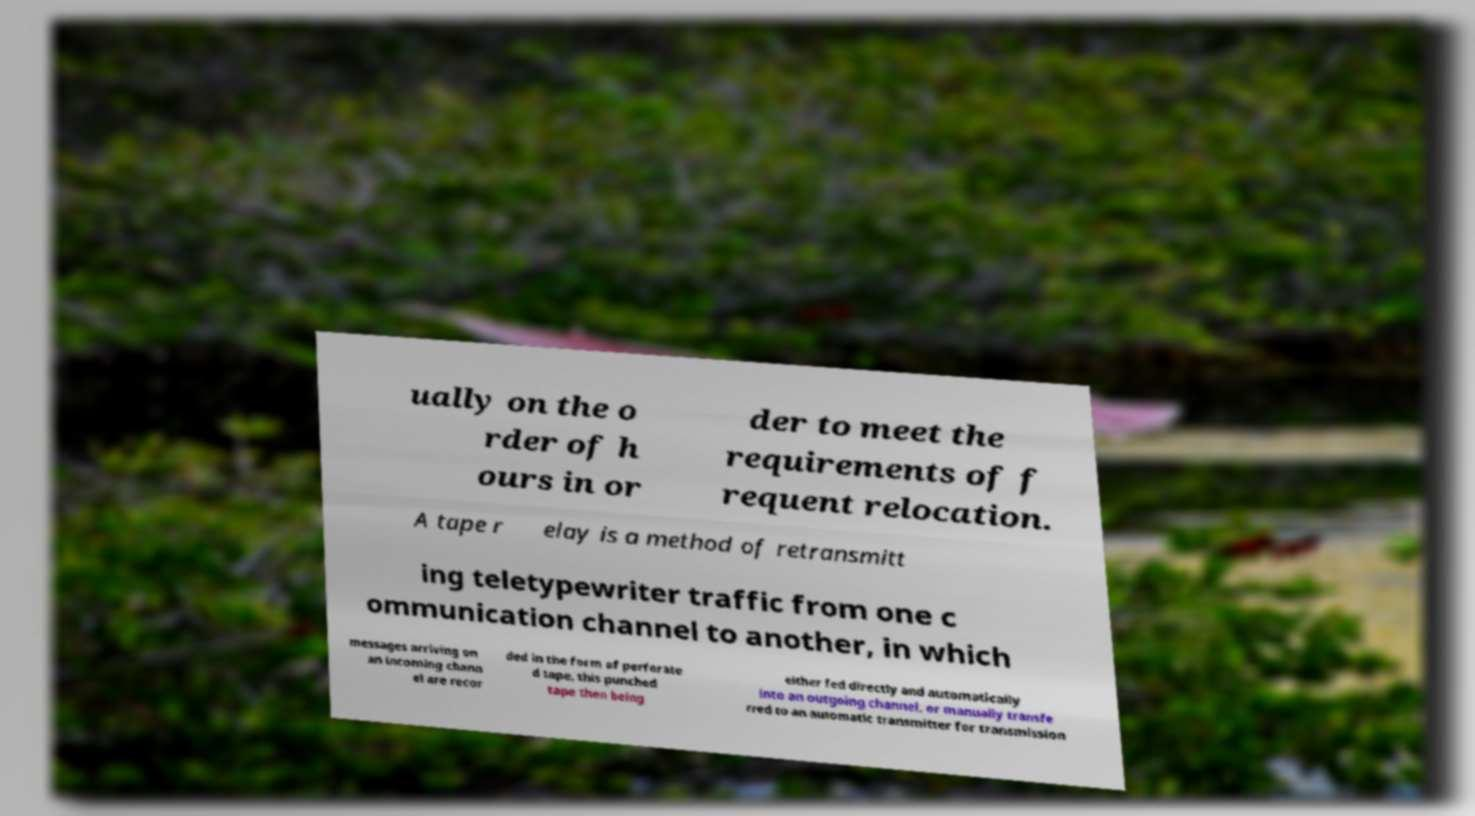Can you accurately transcribe the text from the provided image for me? ually on the o rder of h ours in or der to meet the requirements of f requent relocation. A tape r elay is a method of retransmitt ing teletypewriter traffic from one c ommunication channel to another, in which messages arriving on an incoming chann el are recor ded in the form of perforate d tape, this punched tape then being either fed directly and automatically into an outgoing channel, or manually transfe rred to an automatic transmitter for transmission 